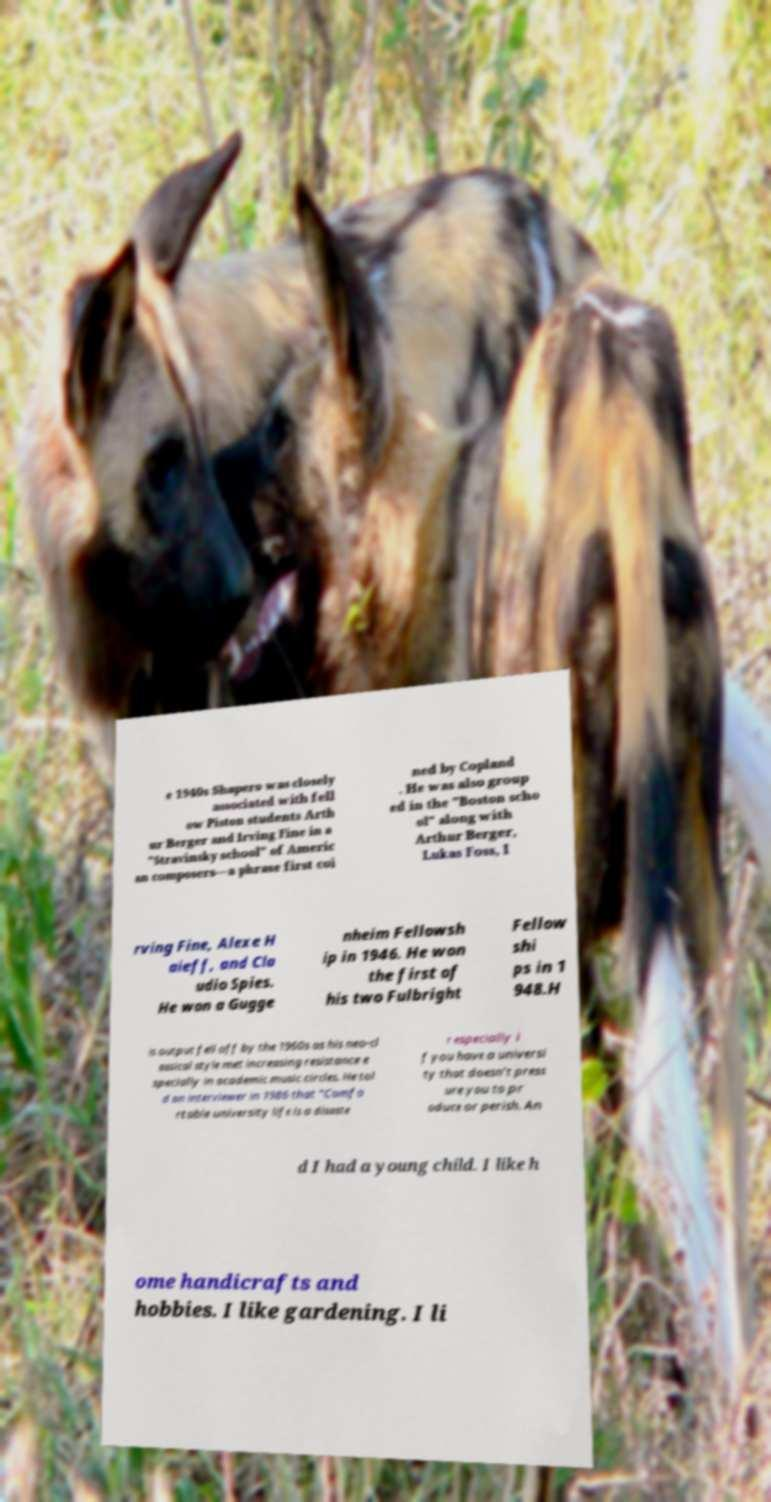Could you assist in decoding the text presented in this image and type it out clearly? e 1940s Shapero was closely associated with fell ow Piston students Arth ur Berger and Irving Fine in a "Stravinsky school" of Americ an composers—a phrase first coi ned by Copland . He was also group ed in the "Boston scho ol" along with Arthur Berger, Lukas Foss, I rving Fine, Alexe H aieff, and Cla udio Spies. He won a Gugge nheim Fellowsh ip in 1946. He won the first of his two Fulbright Fellow shi ps in 1 948.H is output fell off by the 1960s as his neo-cl assical style met increasing resistance e specially in academic music circles. He tol d an interviewer in 1986 that "Comfo rtable university life is a disaste r especially i f you have a universi ty that doesn’t press ure you to pr oduce or perish. An d I had a young child. I like h ome handicrafts and hobbies. I like gardening. I li 